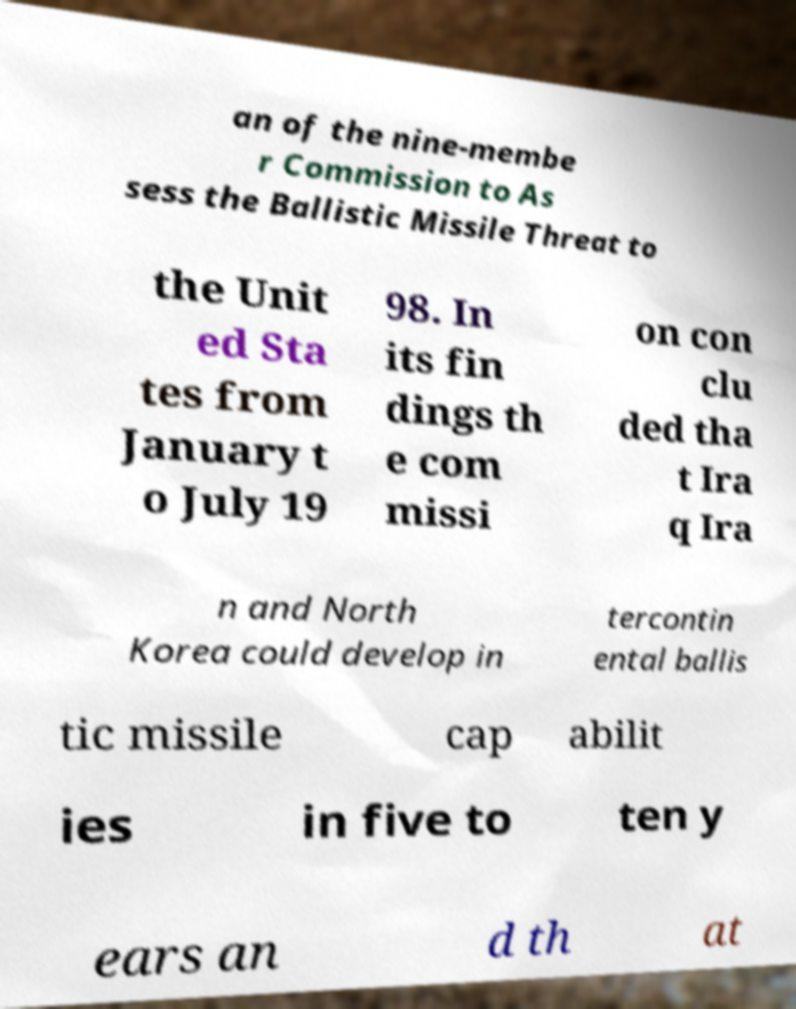For documentation purposes, I need the text within this image transcribed. Could you provide that? an of the nine-membe r Commission to As sess the Ballistic Missile Threat to the Unit ed Sta tes from January t o July 19 98. In its fin dings th e com missi on con clu ded tha t Ira q Ira n and North Korea could develop in tercontin ental ballis tic missile cap abilit ies in five to ten y ears an d th at 